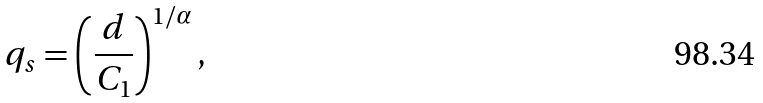Convert formula to latex. <formula><loc_0><loc_0><loc_500><loc_500>q _ { s } = \left ( \frac { d } { C _ { 1 } } \right ) ^ { 1 / \alpha } ,</formula> 